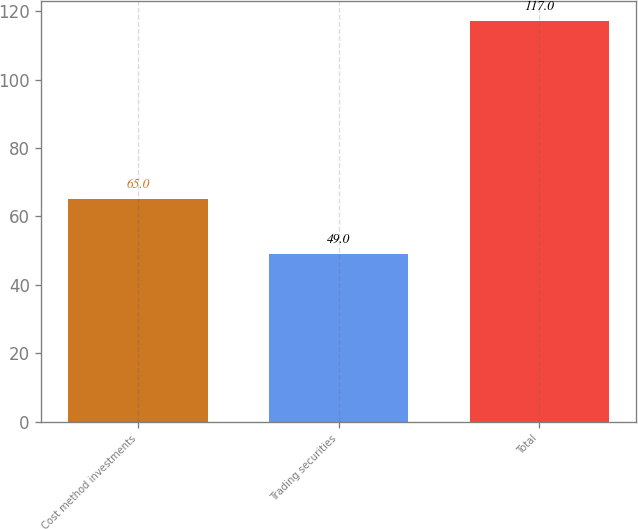Convert chart to OTSL. <chart><loc_0><loc_0><loc_500><loc_500><bar_chart><fcel>Cost method investments<fcel>Trading securities<fcel>Total<nl><fcel>65<fcel>49<fcel>117<nl></chart> 